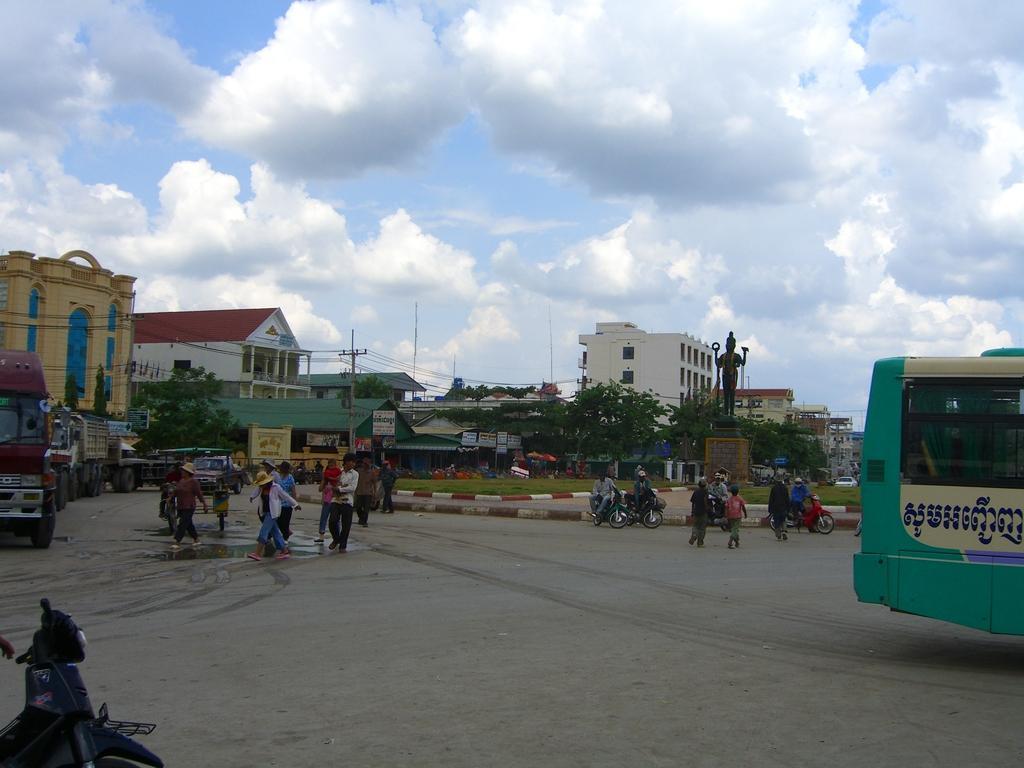Describe this image in one or two sentences. In this image we can see vehicles on the road and there are few persons walking on the road and few persons are sitting on the bikes. In the background there are buildings, poles, wires, statues on a platform, grass on the ground, trees, windows and clouds in the sky. 